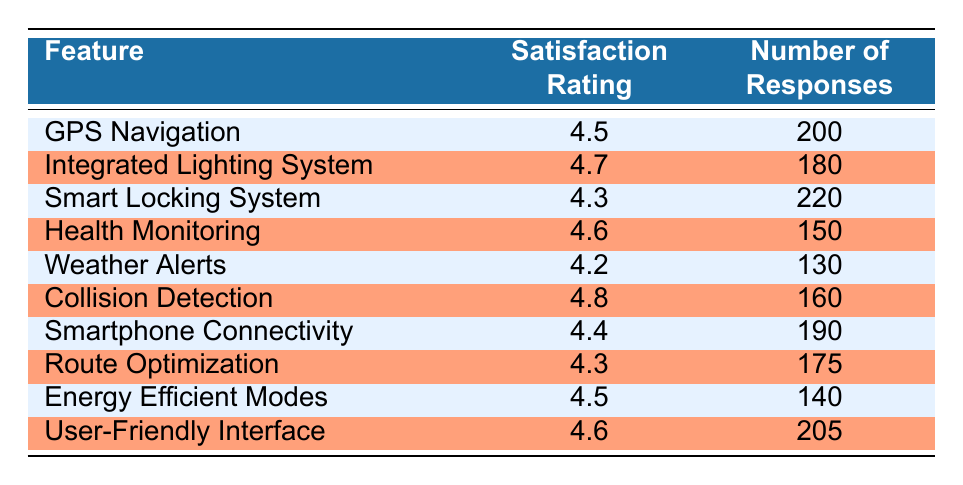What is the satisfaction rating for the Integrated Lighting System? The table lists the satisfaction rating for each feature. For the Integrated Lighting System, it shows a satisfaction rating of 4.7.
Answer: 4.7 How many responses were recorded for the Health Monitoring feature? From the table, the number of responses for the Health Monitoring feature is directly listed as 150.
Answer: 150 Which feature received the highest user satisfaction rating? By looking at the satisfaction ratings in the table, Collision Detection has the highest rating of 4.8 compared to the others.
Answer: Collision Detection What is the average satisfaction rating of the features that received more than 180 responses? First, identify the features with more than 180 responses: GPS Navigation (200), Smart Locking System (220), Smartphone Connectivity (190), and User-Friendly Interface (205). Their ratings are 4.5, 4.3, 4.4, and 4.6 respectively. The sum is 4.5 + 4.3 + 4.4 + 4.6 = 17.8. The average is 17.8 / 4 = 4.45.
Answer: 4.45 Is the satisfaction rating for Weather Alerts higher than that for Smart Locking System? The table shows that Weather Alerts has a rating of 4.2 and Smart Locking System has a rating of 4.3. Since 4.2 is less than 4.3, the answer is no.
Answer: No 